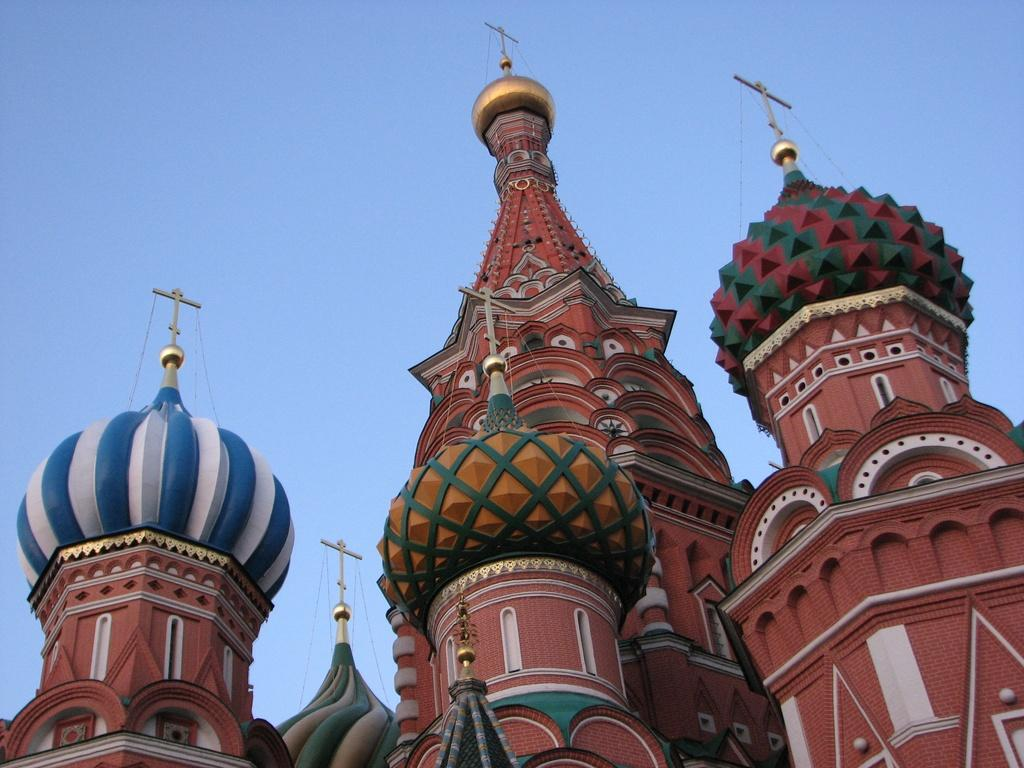What colors can be seen on the building in the image? The building in the image has multiple colors, including brown, blue, white, red, green, and yellow. What is visible in the background of the image? The background of the image contains a blue sky. Can you see a tin can on the seashore in the image? There is no seashore or tin can present in the image; it features a building with a blue sky in the background. 